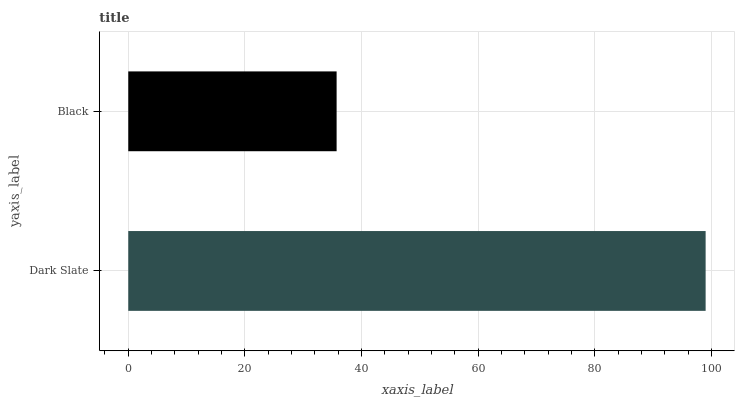Is Black the minimum?
Answer yes or no. Yes. Is Dark Slate the maximum?
Answer yes or no. Yes. Is Black the maximum?
Answer yes or no. No. Is Dark Slate greater than Black?
Answer yes or no. Yes. Is Black less than Dark Slate?
Answer yes or no. Yes. Is Black greater than Dark Slate?
Answer yes or no. No. Is Dark Slate less than Black?
Answer yes or no. No. Is Dark Slate the high median?
Answer yes or no. Yes. Is Black the low median?
Answer yes or no. Yes. Is Black the high median?
Answer yes or no. No. Is Dark Slate the low median?
Answer yes or no. No. 